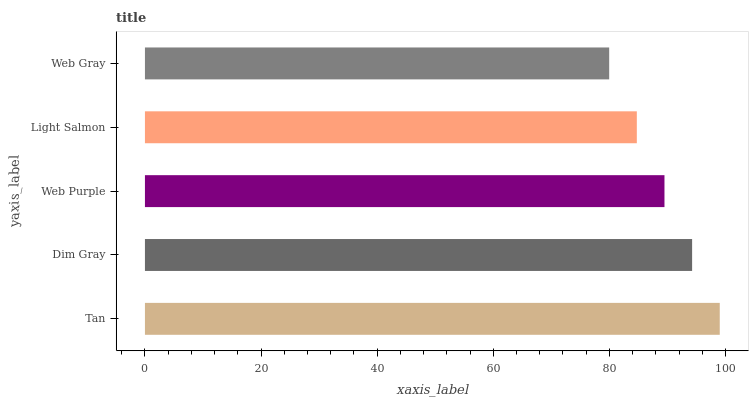Is Web Gray the minimum?
Answer yes or no. Yes. Is Tan the maximum?
Answer yes or no. Yes. Is Dim Gray the minimum?
Answer yes or no. No. Is Dim Gray the maximum?
Answer yes or no. No. Is Tan greater than Dim Gray?
Answer yes or no. Yes. Is Dim Gray less than Tan?
Answer yes or no. Yes. Is Dim Gray greater than Tan?
Answer yes or no. No. Is Tan less than Dim Gray?
Answer yes or no. No. Is Web Purple the high median?
Answer yes or no. Yes. Is Web Purple the low median?
Answer yes or no. Yes. Is Tan the high median?
Answer yes or no. No. Is Dim Gray the low median?
Answer yes or no. No. 